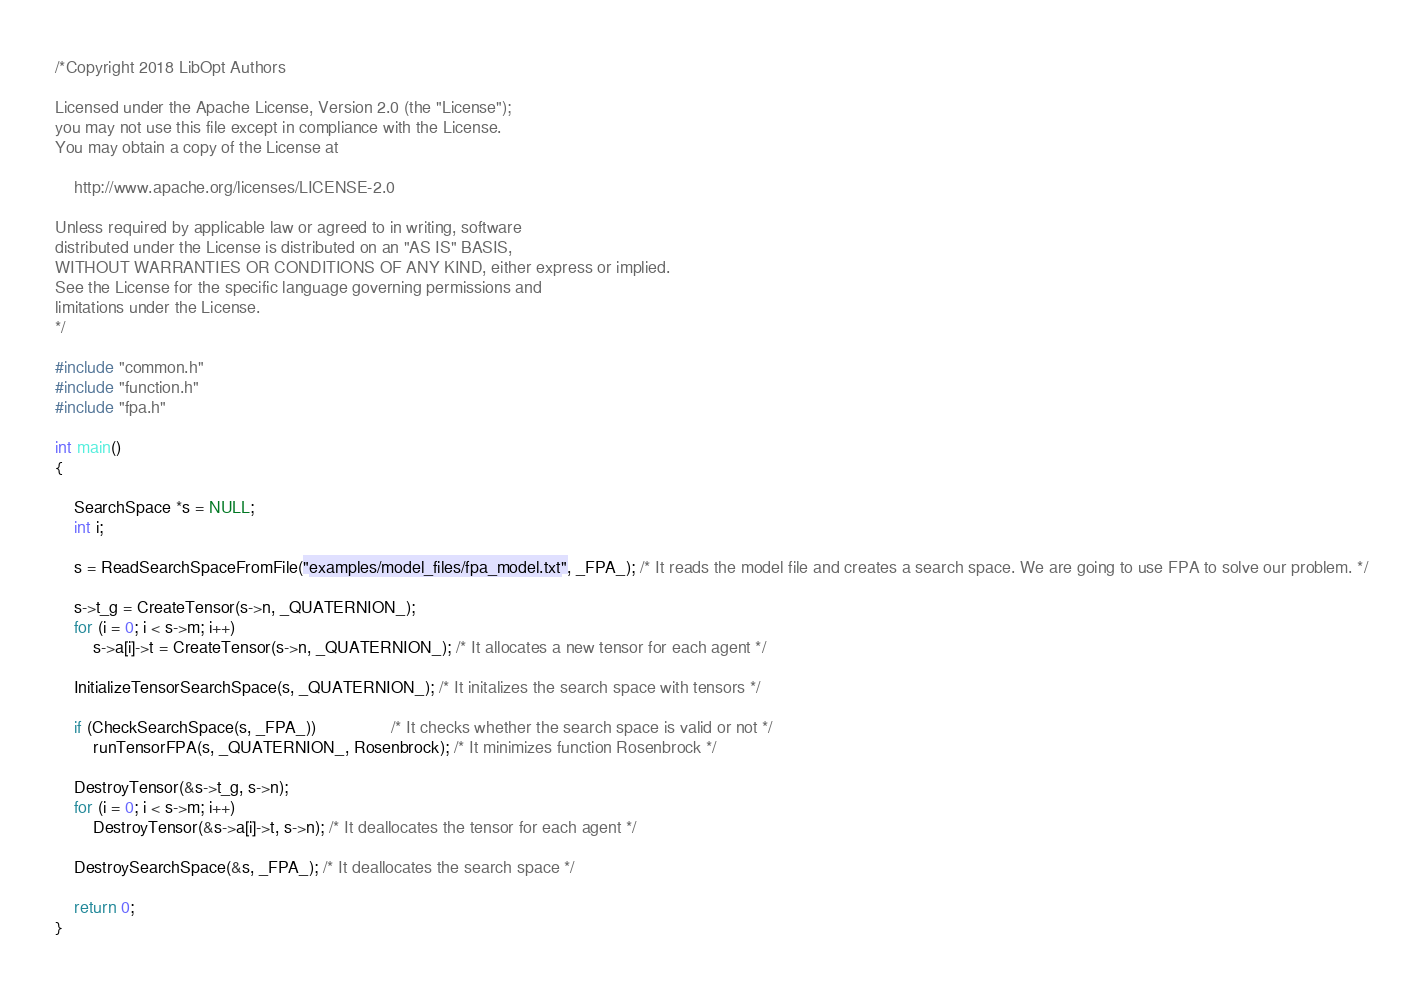<code> <loc_0><loc_0><loc_500><loc_500><_C_>/*Copyright 2018 LibOpt Authors

Licensed under the Apache License, Version 2.0 (the "License");
you may not use this file except in compliance with the License.
You may obtain a copy of the License at

    http://www.apache.org/licenses/LICENSE-2.0

Unless required by applicable law or agreed to in writing, software
distributed under the License is distributed on an "AS IS" BASIS,
WITHOUT WARRANTIES OR CONDITIONS OF ANY KIND, either express or implied.
See the License for the specific language governing permissions and
limitations under the License.
*/

#include "common.h"
#include "function.h"
#include "fpa.h"

int main()
{

    SearchSpace *s = NULL;
    int i;

    s = ReadSearchSpaceFromFile("examples/model_files/fpa_model.txt", _FPA_); /* It reads the model file and creates a search space. We are going to use FPA to solve our problem. */

    s->t_g = CreateTensor(s->n, _QUATERNION_);
    for (i = 0; i < s->m; i++)
        s->a[i]->t = CreateTensor(s->n, _QUATERNION_); /* It allocates a new tensor for each agent */

    InitializeTensorSearchSpace(s, _QUATERNION_); /* It initalizes the search space with tensors */

    if (CheckSearchSpace(s, _FPA_))                /* It checks whether the search space is valid or not */
        runTensorFPA(s, _QUATERNION_, Rosenbrock); /* It minimizes function Rosenbrock */

    DestroyTensor(&s->t_g, s->n);
    for (i = 0; i < s->m; i++)
        DestroyTensor(&s->a[i]->t, s->n); /* It deallocates the tensor for each agent */

    DestroySearchSpace(&s, _FPA_); /* It deallocates the search space */

    return 0;
}
</code> 